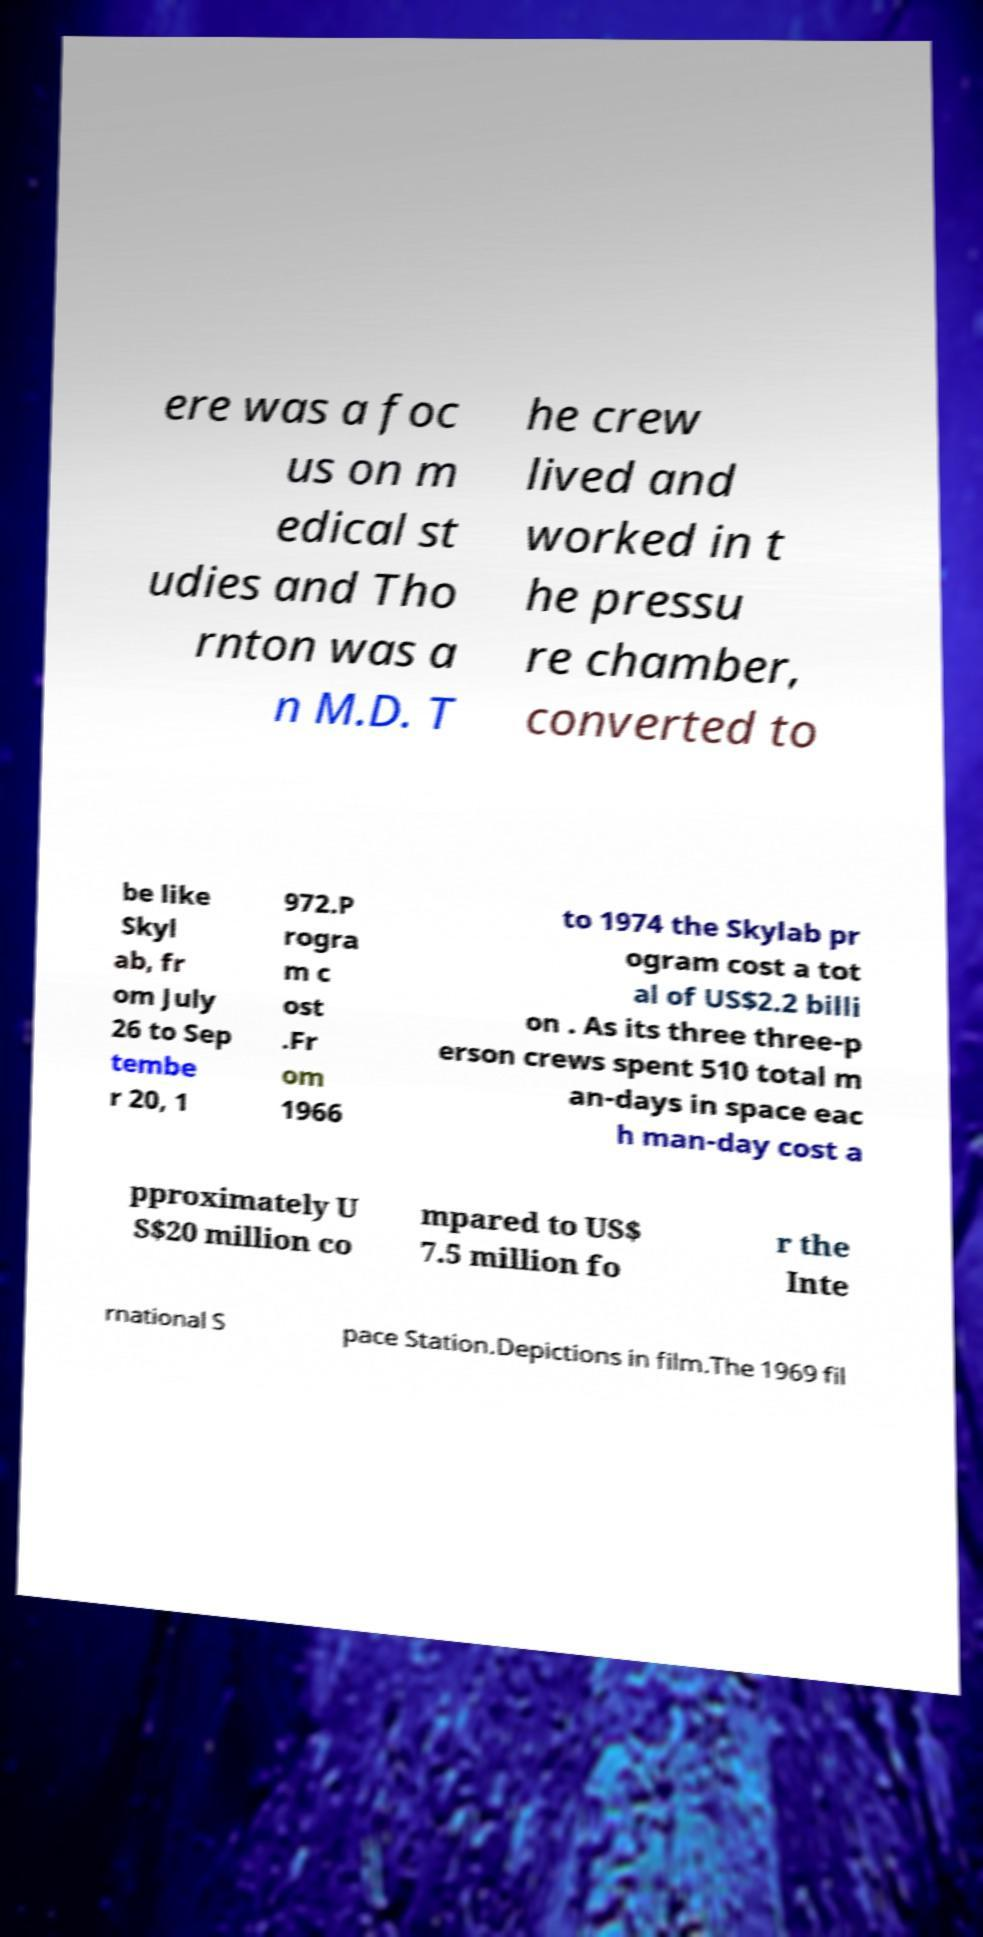Please read and relay the text visible in this image. What does it say? ere was a foc us on m edical st udies and Tho rnton was a n M.D. T he crew lived and worked in t he pressu re chamber, converted to be like Skyl ab, fr om July 26 to Sep tembe r 20, 1 972.P rogra m c ost .Fr om 1966 to 1974 the Skylab pr ogram cost a tot al of US$2.2 billi on . As its three three-p erson crews spent 510 total m an-days in space eac h man-day cost a pproximately U S$20 million co mpared to US$ 7.5 million fo r the Inte rnational S pace Station.Depictions in film.The 1969 fil 